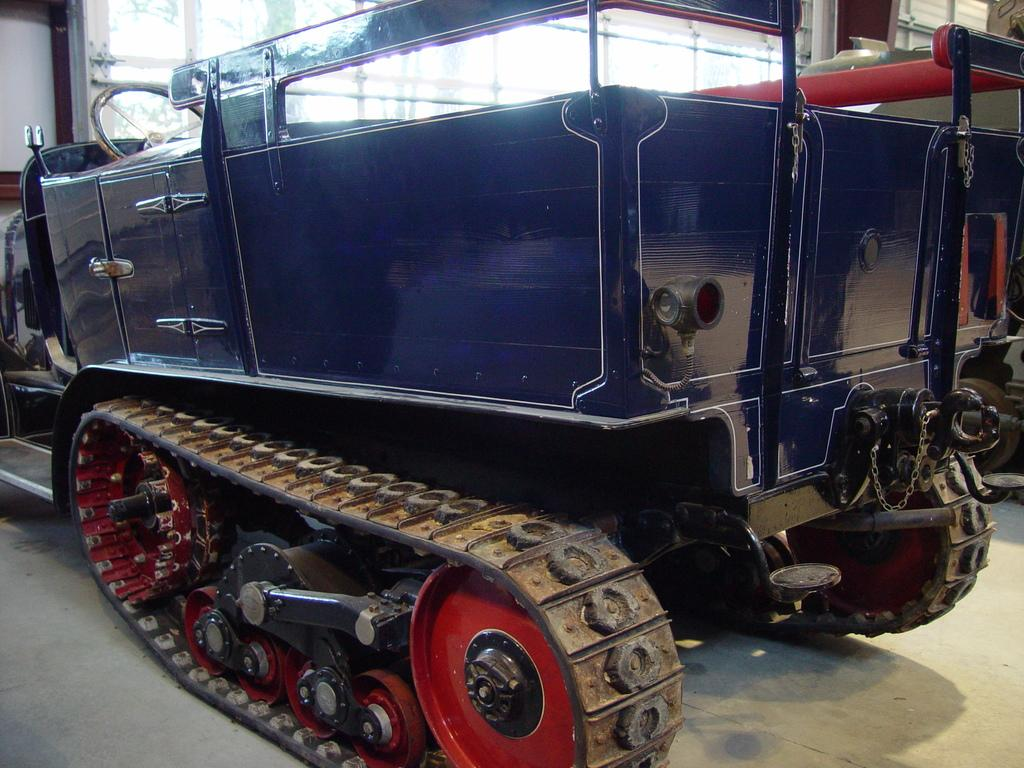What type of vehicle is in the image? There is an artillery tractor in the image. Where is the artillery tractor located in the image? The artillery tractor is in the front of the image. What is used to control the direction of the artillery tractor? There is a steering wheel on the left side of the artillery tractor. What can be seen in the background of the image? There is glass visible in the background of the image. What type of quill is used to write on the scale in the image? There is no quill or scale present in the image; it features an artillery tractor with a steering wheel and glass in the background. 